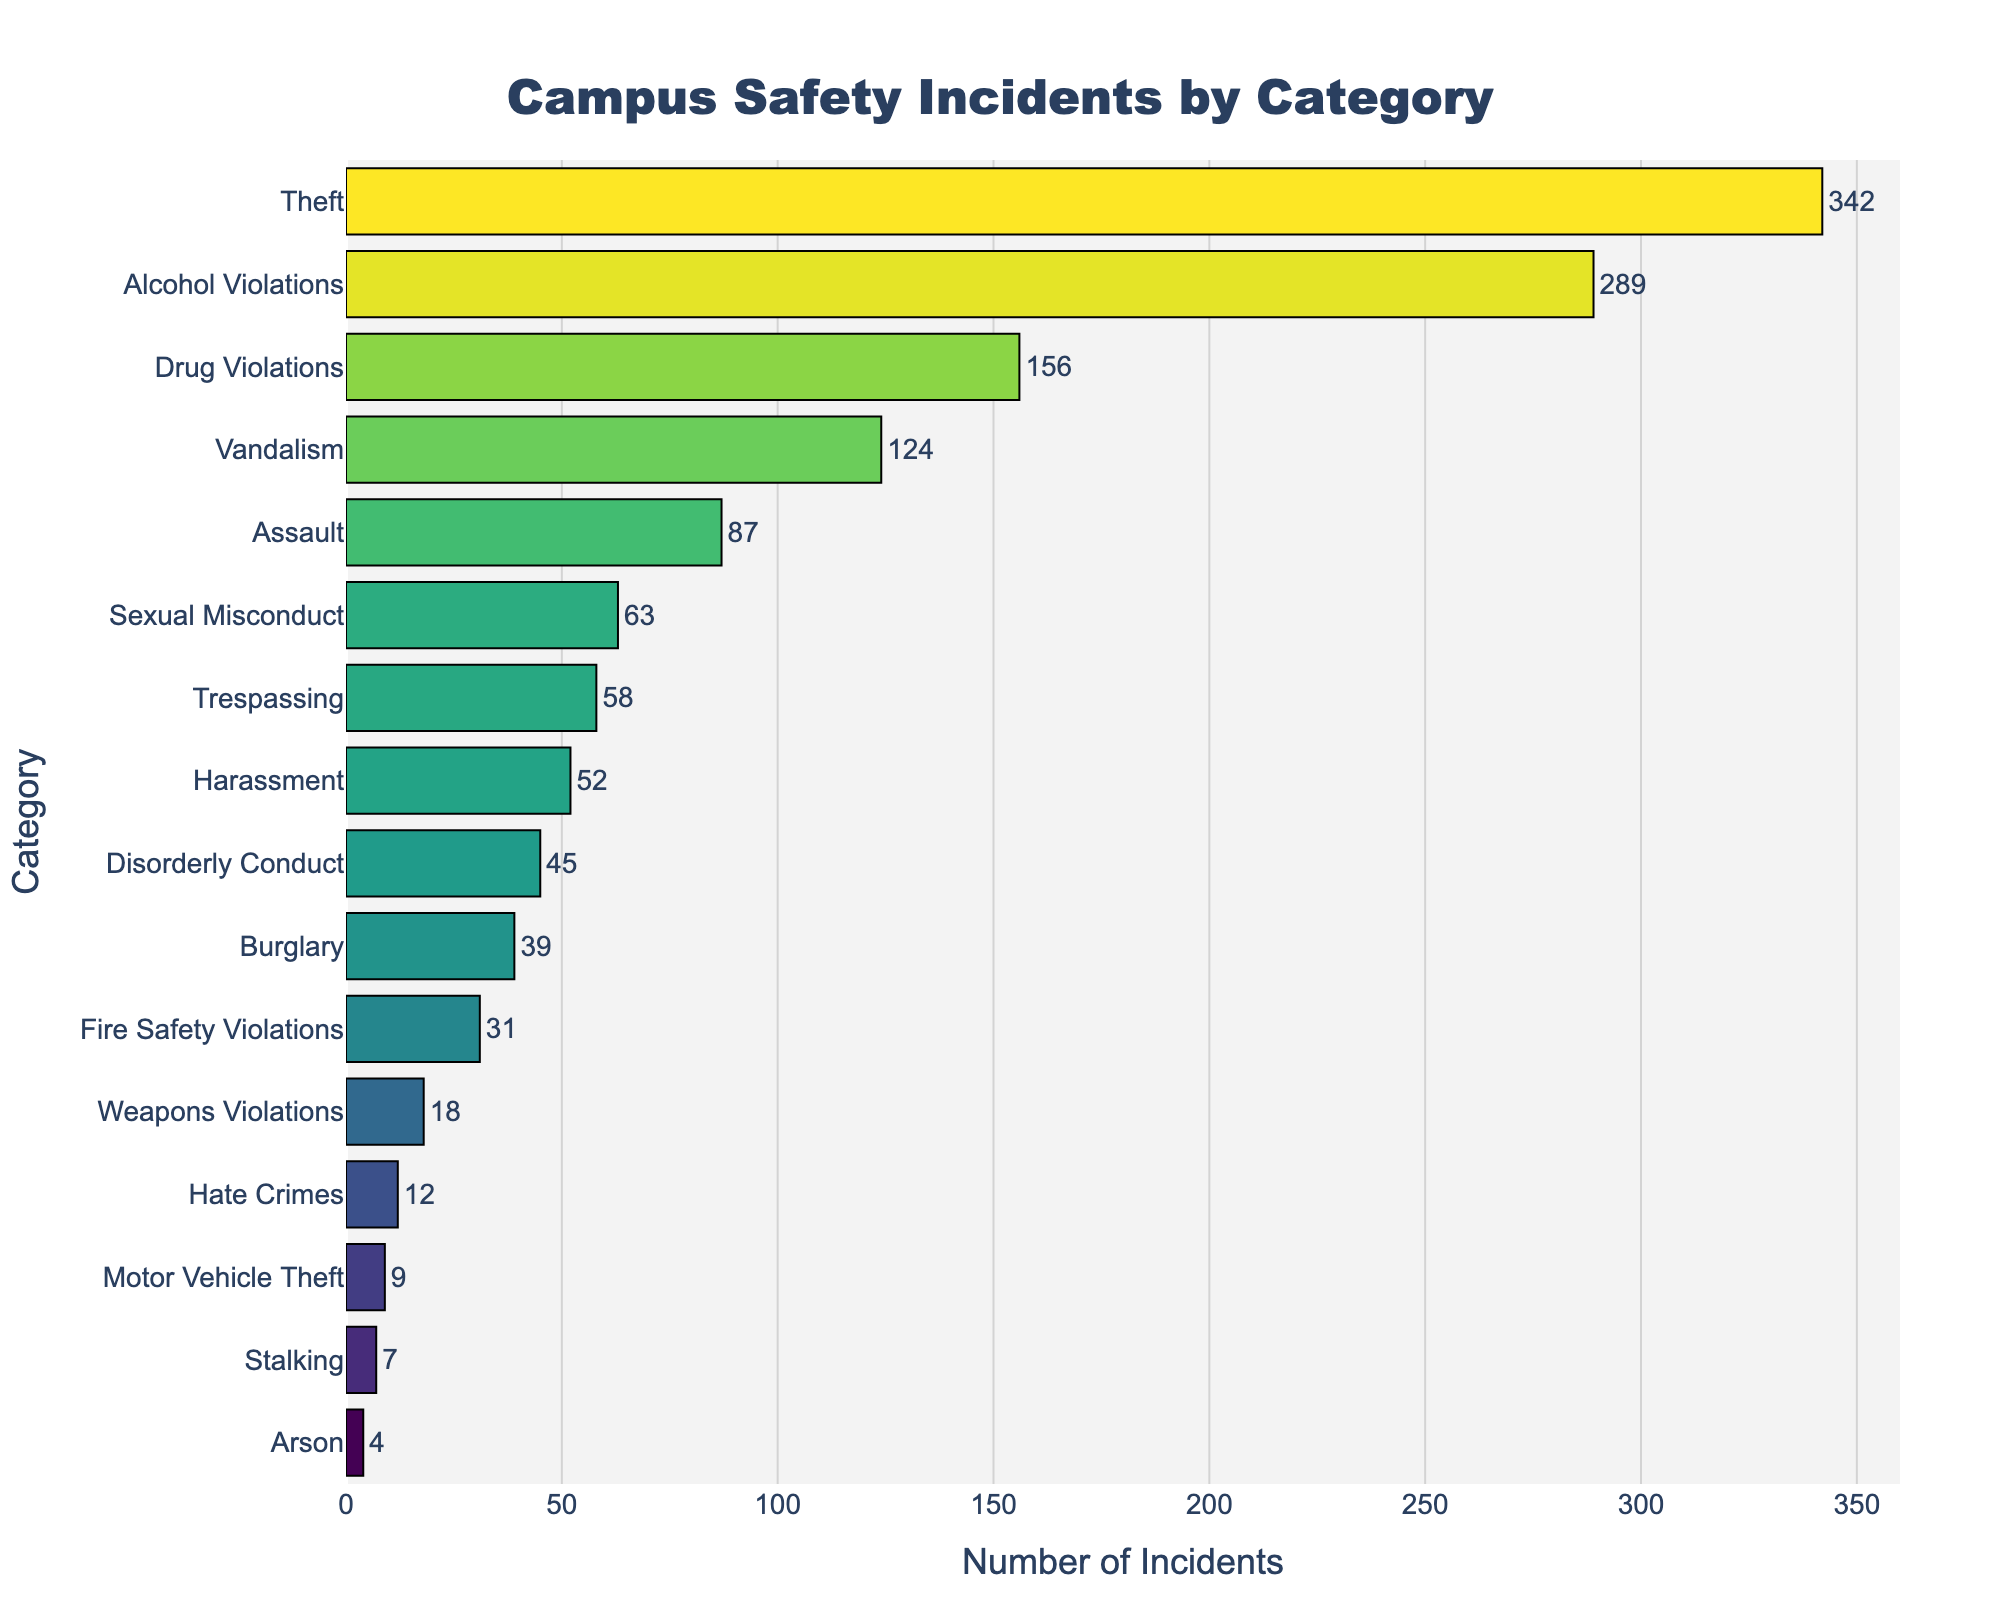Which category has the highest number of incidents? The bar for 'Theft' is the longest, indicating it has the highest number of incidents.
Answer: Theft Which category has fewer incidents, 'Harassment' or 'Disorderly Conduct'? By comparing the lengths of the bars, 'Disorderly Conduct' has 45 incidents, while 'Harassment' has 52 incidents.
Answer: Disorderly Conduct What is the total number of incidents for 'Theft', 'Alcohol Violations', and 'Drug Violations'? Add the numbers of incidents: 342 (Theft) + 289 (Alcohol Violations) + 156 (Drug Violations) = 787.
Answer: 787 Which category has close to half the number of incidents as 'Alcohol Violations'? 'Alcohol Violations' has 289 incidents. Half of 289 is approximately 144.5. 'Vandalism' with 124 is closest to this number.
Answer: Vandalism How does the number of 'Sexual Misconduct' incidents compare to 'Assault'? The bar for 'Sexual Misconduct' is shorter with 63 incidents, while 'Assault' has 87 incidents.
Answer: Sexual Misconduct has fewer incidents than Assault What is the combined number of incidents for 'Arson' and 'Stalking'? Add the numbers of incidents: 4 (Arson) + 7 (Stalking) = 11.
Answer: 11 Is the number of 'Weapons Violations' incidents greater than 'Fire Safety Violations'? Compare the lengths of the bars; 'Weapons Violations' has 18 incidents, and 'Fire Safety Violations' has 31 incidents.
Answer: No Which three categories have the least number of incidents? Looking at the shortest bars, 'Arson' (4 incidents), 'Stalking' (7 incidents), and 'Motor Vehicle Theft' (9 incidents) have the least.
Answer: Arson, Stalking, Motor Vehicle Theft What is the proportional difference between 'Burglary' and 'Vandalism' incidents? 'Burglary' has 39 incidents and 'Vandalism' has 124 incidents. The difference is 124 - 39 = 85 incidents. The proportional difference is 85/124 = approximately 0.685.
Answer: 0.685 How many categories have more than 100 incidents? 'Theft', 'Alcohol Violations', 'Drug Violations', and 'Vandalism' have more than 100 incidents, totaling four categories.
Answer: 4 